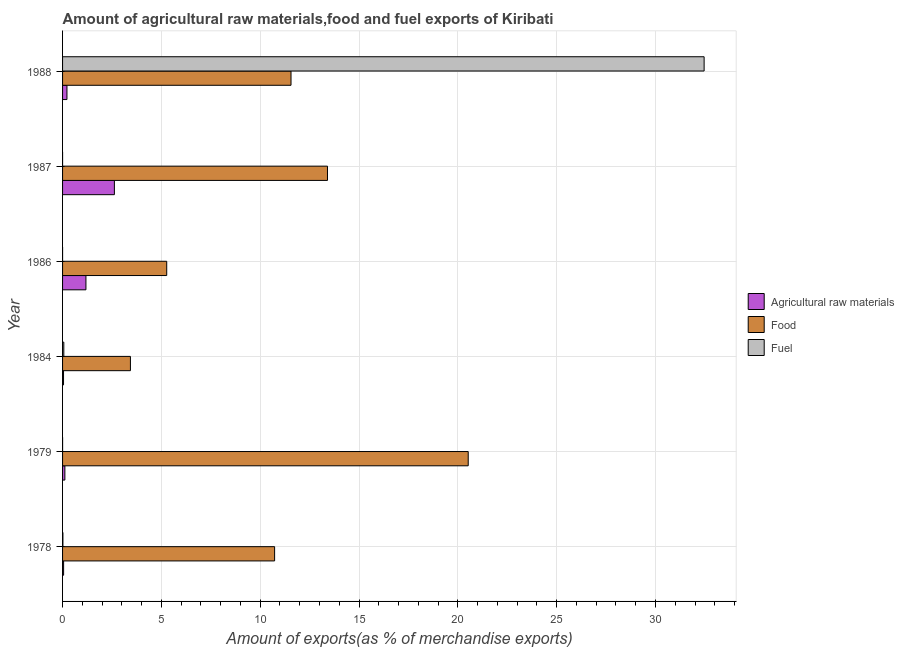Are the number of bars per tick equal to the number of legend labels?
Provide a succinct answer. Yes. Are the number of bars on each tick of the Y-axis equal?
Offer a very short reply. Yes. What is the percentage of fuel exports in 1978?
Make the answer very short. 0.02. Across all years, what is the maximum percentage of fuel exports?
Make the answer very short. 32.46. Across all years, what is the minimum percentage of raw materials exports?
Offer a terse response. 0.05. In which year was the percentage of food exports maximum?
Ensure brevity in your answer.  1979. What is the total percentage of fuel exports in the graph?
Provide a succinct answer. 32.54. What is the difference between the percentage of food exports in 1978 and that in 1979?
Keep it short and to the point. -9.79. What is the difference between the percentage of fuel exports in 1987 and the percentage of food exports in 1978?
Your answer should be very brief. -10.73. What is the average percentage of fuel exports per year?
Keep it short and to the point. 5.42. In the year 1988, what is the difference between the percentage of food exports and percentage of raw materials exports?
Make the answer very short. 11.34. What is the ratio of the percentage of fuel exports in 1979 to that in 1984?
Ensure brevity in your answer.  0. Is the difference between the percentage of raw materials exports in 1978 and 1987 greater than the difference between the percentage of fuel exports in 1978 and 1987?
Your answer should be very brief. No. What is the difference between the highest and the second highest percentage of raw materials exports?
Your answer should be very brief. 1.44. What is the difference between the highest and the lowest percentage of fuel exports?
Keep it short and to the point. 32.46. In how many years, is the percentage of fuel exports greater than the average percentage of fuel exports taken over all years?
Keep it short and to the point. 1. Is the sum of the percentage of raw materials exports in 1979 and 1987 greater than the maximum percentage of fuel exports across all years?
Offer a very short reply. No. What does the 1st bar from the top in 1986 represents?
Your answer should be compact. Fuel. What does the 2nd bar from the bottom in 1984 represents?
Keep it short and to the point. Food. Is it the case that in every year, the sum of the percentage of raw materials exports and percentage of food exports is greater than the percentage of fuel exports?
Provide a short and direct response. No. How many bars are there?
Keep it short and to the point. 18. Are all the bars in the graph horizontal?
Provide a succinct answer. Yes. How many years are there in the graph?
Keep it short and to the point. 6. Are the values on the major ticks of X-axis written in scientific E-notation?
Make the answer very short. No. Does the graph contain any zero values?
Provide a short and direct response. No. Does the graph contain grids?
Provide a succinct answer. Yes. Where does the legend appear in the graph?
Your response must be concise. Center right. How are the legend labels stacked?
Ensure brevity in your answer.  Vertical. What is the title of the graph?
Provide a short and direct response. Amount of agricultural raw materials,food and fuel exports of Kiribati. Does "Male employers" appear as one of the legend labels in the graph?
Your answer should be very brief. No. What is the label or title of the X-axis?
Your answer should be very brief. Amount of exports(as % of merchandise exports). What is the Amount of exports(as % of merchandise exports) in Agricultural raw materials in 1978?
Your answer should be compact. 0.05. What is the Amount of exports(as % of merchandise exports) in Food in 1978?
Make the answer very short. 10.73. What is the Amount of exports(as % of merchandise exports) in Fuel in 1978?
Provide a short and direct response. 0.02. What is the Amount of exports(as % of merchandise exports) of Agricultural raw materials in 1979?
Offer a terse response. 0.12. What is the Amount of exports(as % of merchandise exports) of Food in 1979?
Provide a succinct answer. 20.52. What is the Amount of exports(as % of merchandise exports) in Fuel in 1979?
Your response must be concise. 0. What is the Amount of exports(as % of merchandise exports) in Agricultural raw materials in 1984?
Offer a terse response. 0.05. What is the Amount of exports(as % of merchandise exports) of Food in 1984?
Offer a very short reply. 3.43. What is the Amount of exports(as % of merchandise exports) in Fuel in 1984?
Make the answer very short. 0.06. What is the Amount of exports(as % of merchandise exports) in Agricultural raw materials in 1986?
Provide a succinct answer. 1.18. What is the Amount of exports(as % of merchandise exports) in Food in 1986?
Your response must be concise. 5.27. What is the Amount of exports(as % of merchandise exports) of Fuel in 1986?
Provide a succinct answer. 0. What is the Amount of exports(as % of merchandise exports) of Agricultural raw materials in 1987?
Keep it short and to the point. 2.62. What is the Amount of exports(as % of merchandise exports) of Food in 1987?
Your answer should be compact. 13.4. What is the Amount of exports(as % of merchandise exports) in Fuel in 1987?
Offer a terse response. 0. What is the Amount of exports(as % of merchandise exports) of Agricultural raw materials in 1988?
Keep it short and to the point. 0.22. What is the Amount of exports(as % of merchandise exports) of Food in 1988?
Provide a succinct answer. 11.56. What is the Amount of exports(as % of merchandise exports) in Fuel in 1988?
Make the answer very short. 32.46. Across all years, what is the maximum Amount of exports(as % of merchandise exports) in Agricultural raw materials?
Your answer should be compact. 2.62. Across all years, what is the maximum Amount of exports(as % of merchandise exports) in Food?
Offer a very short reply. 20.52. Across all years, what is the maximum Amount of exports(as % of merchandise exports) of Fuel?
Ensure brevity in your answer.  32.46. Across all years, what is the minimum Amount of exports(as % of merchandise exports) in Agricultural raw materials?
Provide a succinct answer. 0.05. Across all years, what is the minimum Amount of exports(as % of merchandise exports) in Food?
Provide a succinct answer. 3.43. Across all years, what is the minimum Amount of exports(as % of merchandise exports) in Fuel?
Offer a very short reply. 0. What is the total Amount of exports(as % of merchandise exports) in Agricultural raw materials in the graph?
Give a very brief answer. 4.25. What is the total Amount of exports(as % of merchandise exports) in Food in the graph?
Ensure brevity in your answer.  64.92. What is the total Amount of exports(as % of merchandise exports) of Fuel in the graph?
Provide a succinct answer. 32.54. What is the difference between the Amount of exports(as % of merchandise exports) of Agricultural raw materials in 1978 and that in 1979?
Your answer should be very brief. -0.06. What is the difference between the Amount of exports(as % of merchandise exports) in Food in 1978 and that in 1979?
Keep it short and to the point. -9.8. What is the difference between the Amount of exports(as % of merchandise exports) of Fuel in 1978 and that in 1979?
Ensure brevity in your answer.  0.02. What is the difference between the Amount of exports(as % of merchandise exports) in Agricultural raw materials in 1978 and that in 1984?
Offer a very short reply. 0. What is the difference between the Amount of exports(as % of merchandise exports) in Food in 1978 and that in 1984?
Ensure brevity in your answer.  7.29. What is the difference between the Amount of exports(as % of merchandise exports) in Fuel in 1978 and that in 1984?
Ensure brevity in your answer.  -0.05. What is the difference between the Amount of exports(as % of merchandise exports) in Agricultural raw materials in 1978 and that in 1986?
Provide a short and direct response. -1.13. What is the difference between the Amount of exports(as % of merchandise exports) of Food in 1978 and that in 1986?
Offer a terse response. 5.46. What is the difference between the Amount of exports(as % of merchandise exports) in Fuel in 1978 and that in 1986?
Provide a short and direct response. 0.02. What is the difference between the Amount of exports(as % of merchandise exports) in Agricultural raw materials in 1978 and that in 1987?
Your response must be concise. -2.57. What is the difference between the Amount of exports(as % of merchandise exports) of Food in 1978 and that in 1987?
Your response must be concise. -2.68. What is the difference between the Amount of exports(as % of merchandise exports) of Fuel in 1978 and that in 1987?
Give a very brief answer. 0.02. What is the difference between the Amount of exports(as % of merchandise exports) of Agricultural raw materials in 1978 and that in 1988?
Give a very brief answer. -0.17. What is the difference between the Amount of exports(as % of merchandise exports) in Food in 1978 and that in 1988?
Your answer should be compact. -0.83. What is the difference between the Amount of exports(as % of merchandise exports) of Fuel in 1978 and that in 1988?
Provide a succinct answer. -32.44. What is the difference between the Amount of exports(as % of merchandise exports) of Agricultural raw materials in 1979 and that in 1984?
Provide a succinct answer. 0.07. What is the difference between the Amount of exports(as % of merchandise exports) in Food in 1979 and that in 1984?
Make the answer very short. 17.09. What is the difference between the Amount of exports(as % of merchandise exports) in Fuel in 1979 and that in 1984?
Offer a very short reply. -0.06. What is the difference between the Amount of exports(as % of merchandise exports) in Agricultural raw materials in 1979 and that in 1986?
Offer a very short reply. -1.07. What is the difference between the Amount of exports(as % of merchandise exports) of Food in 1979 and that in 1986?
Ensure brevity in your answer.  15.25. What is the difference between the Amount of exports(as % of merchandise exports) in Fuel in 1979 and that in 1986?
Offer a terse response. 0. What is the difference between the Amount of exports(as % of merchandise exports) of Agricultural raw materials in 1979 and that in 1987?
Keep it short and to the point. -2.51. What is the difference between the Amount of exports(as % of merchandise exports) of Food in 1979 and that in 1987?
Give a very brief answer. 7.12. What is the difference between the Amount of exports(as % of merchandise exports) in Agricultural raw materials in 1979 and that in 1988?
Provide a succinct answer. -0.11. What is the difference between the Amount of exports(as % of merchandise exports) of Food in 1979 and that in 1988?
Give a very brief answer. 8.96. What is the difference between the Amount of exports(as % of merchandise exports) in Fuel in 1979 and that in 1988?
Offer a terse response. -32.46. What is the difference between the Amount of exports(as % of merchandise exports) of Agricultural raw materials in 1984 and that in 1986?
Your response must be concise. -1.13. What is the difference between the Amount of exports(as % of merchandise exports) in Food in 1984 and that in 1986?
Your response must be concise. -1.84. What is the difference between the Amount of exports(as % of merchandise exports) of Fuel in 1984 and that in 1986?
Provide a succinct answer. 0.06. What is the difference between the Amount of exports(as % of merchandise exports) of Agricultural raw materials in 1984 and that in 1987?
Offer a very short reply. -2.57. What is the difference between the Amount of exports(as % of merchandise exports) in Food in 1984 and that in 1987?
Ensure brevity in your answer.  -9.97. What is the difference between the Amount of exports(as % of merchandise exports) in Fuel in 1984 and that in 1987?
Offer a very short reply. 0.06. What is the difference between the Amount of exports(as % of merchandise exports) of Agricultural raw materials in 1984 and that in 1988?
Offer a very short reply. -0.17. What is the difference between the Amount of exports(as % of merchandise exports) in Food in 1984 and that in 1988?
Offer a very short reply. -8.13. What is the difference between the Amount of exports(as % of merchandise exports) in Fuel in 1984 and that in 1988?
Ensure brevity in your answer.  -32.4. What is the difference between the Amount of exports(as % of merchandise exports) in Agricultural raw materials in 1986 and that in 1987?
Make the answer very short. -1.44. What is the difference between the Amount of exports(as % of merchandise exports) of Food in 1986 and that in 1987?
Give a very brief answer. -8.13. What is the difference between the Amount of exports(as % of merchandise exports) in Fuel in 1986 and that in 1987?
Give a very brief answer. -0. What is the difference between the Amount of exports(as % of merchandise exports) in Agricultural raw materials in 1986 and that in 1988?
Offer a terse response. 0.96. What is the difference between the Amount of exports(as % of merchandise exports) of Food in 1986 and that in 1988?
Your answer should be compact. -6.29. What is the difference between the Amount of exports(as % of merchandise exports) in Fuel in 1986 and that in 1988?
Give a very brief answer. -32.46. What is the difference between the Amount of exports(as % of merchandise exports) in Agricultural raw materials in 1987 and that in 1988?
Provide a short and direct response. 2.4. What is the difference between the Amount of exports(as % of merchandise exports) of Food in 1987 and that in 1988?
Ensure brevity in your answer.  1.85. What is the difference between the Amount of exports(as % of merchandise exports) of Fuel in 1987 and that in 1988?
Offer a very short reply. -32.46. What is the difference between the Amount of exports(as % of merchandise exports) in Agricultural raw materials in 1978 and the Amount of exports(as % of merchandise exports) in Food in 1979?
Keep it short and to the point. -20.47. What is the difference between the Amount of exports(as % of merchandise exports) of Agricultural raw materials in 1978 and the Amount of exports(as % of merchandise exports) of Fuel in 1979?
Make the answer very short. 0.05. What is the difference between the Amount of exports(as % of merchandise exports) in Food in 1978 and the Amount of exports(as % of merchandise exports) in Fuel in 1979?
Provide a succinct answer. 10.73. What is the difference between the Amount of exports(as % of merchandise exports) in Agricultural raw materials in 1978 and the Amount of exports(as % of merchandise exports) in Food in 1984?
Keep it short and to the point. -3.38. What is the difference between the Amount of exports(as % of merchandise exports) of Agricultural raw materials in 1978 and the Amount of exports(as % of merchandise exports) of Fuel in 1984?
Ensure brevity in your answer.  -0.01. What is the difference between the Amount of exports(as % of merchandise exports) of Food in 1978 and the Amount of exports(as % of merchandise exports) of Fuel in 1984?
Your answer should be very brief. 10.67. What is the difference between the Amount of exports(as % of merchandise exports) in Agricultural raw materials in 1978 and the Amount of exports(as % of merchandise exports) in Food in 1986?
Your response must be concise. -5.22. What is the difference between the Amount of exports(as % of merchandise exports) in Agricultural raw materials in 1978 and the Amount of exports(as % of merchandise exports) in Fuel in 1986?
Make the answer very short. 0.05. What is the difference between the Amount of exports(as % of merchandise exports) of Food in 1978 and the Amount of exports(as % of merchandise exports) of Fuel in 1986?
Your answer should be compact. 10.73. What is the difference between the Amount of exports(as % of merchandise exports) of Agricultural raw materials in 1978 and the Amount of exports(as % of merchandise exports) of Food in 1987?
Provide a succinct answer. -13.35. What is the difference between the Amount of exports(as % of merchandise exports) of Agricultural raw materials in 1978 and the Amount of exports(as % of merchandise exports) of Fuel in 1987?
Provide a succinct answer. 0.05. What is the difference between the Amount of exports(as % of merchandise exports) of Food in 1978 and the Amount of exports(as % of merchandise exports) of Fuel in 1987?
Your answer should be compact. 10.73. What is the difference between the Amount of exports(as % of merchandise exports) in Agricultural raw materials in 1978 and the Amount of exports(as % of merchandise exports) in Food in 1988?
Make the answer very short. -11.51. What is the difference between the Amount of exports(as % of merchandise exports) in Agricultural raw materials in 1978 and the Amount of exports(as % of merchandise exports) in Fuel in 1988?
Keep it short and to the point. -32.41. What is the difference between the Amount of exports(as % of merchandise exports) in Food in 1978 and the Amount of exports(as % of merchandise exports) in Fuel in 1988?
Offer a very short reply. -21.73. What is the difference between the Amount of exports(as % of merchandise exports) of Agricultural raw materials in 1979 and the Amount of exports(as % of merchandise exports) of Food in 1984?
Offer a very short reply. -3.32. What is the difference between the Amount of exports(as % of merchandise exports) of Agricultural raw materials in 1979 and the Amount of exports(as % of merchandise exports) of Fuel in 1984?
Keep it short and to the point. 0.05. What is the difference between the Amount of exports(as % of merchandise exports) of Food in 1979 and the Amount of exports(as % of merchandise exports) of Fuel in 1984?
Your answer should be very brief. 20.46. What is the difference between the Amount of exports(as % of merchandise exports) of Agricultural raw materials in 1979 and the Amount of exports(as % of merchandise exports) of Food in 1986?
Your response must be concise. -5.15. What is the difference between the Amount of exports(as % of merchandise exports) of Agricultural raw materials in 1979 and the Amount of exports(as % of merchandise exports) of Fuel in 1986?
Your answer should be very brief. 0.12. What is the difference between the Amount of exports(as % of merchandise exports) of Food in 1979 and the Amount of exports(as % of merchandise exports) of Fuel in 1986?
Your answer should be compact. 20.52. What is the difference between the Amount of exports(as % of merchandise exports) of Agricultural raw materials in 1979 and the Amount of exports(as % of merchandise exports) of Food in 1987?
Provide a succinct answer. -13.29. What is the difference between the Amount of exports(as % of merchandise exports) in Agricultural raw materials in 1979 and the Amount of exports(as % of merchandise exports) in Fuel in 1987?
Offer a terse response. 0.12. What is the difference between the Amount of exports(as % of merchandise exports) of Food in 1979 and the Amount of exports(as % of merchandise exports) of Fuel in 1987?
Provide a succinct answer. 20.52. What is the difference between the Amount of exports(as % of merchandise exports) in Agricultural raw materials in 1979 and the Amount of exports(as % of merchandise exports) in Food in 1988?
Your answer should be very brief. -11.44. What is the difference between the Amount of exports(as % of merchandise exports) in Agricultural raw materials in 1979 and the Amount of exports(as % of merchandise exports) in Fuel in 1988?
Your answer should be compact. -32.34. What is the difference between the Amount of exports(as % of merchandise exports) of Food in 1979 and the Amount of exports(as % of merchandise exports) of Fuel in 1988?
Your answer should be compact. -11.94. What is the difference between the Amount of exports(as % of merchandise exports) of Agricultural raw materials in 1984 and the Amount of exports(as % of merchandise exports) of Food in 1986?
Provide a short and direct response. -5.22. What is the difference between the Amount of exports(as % of merchandise exports) of Agricultural raw materials in 1984 and the Amount of exports(as % of merchandise exports) of Fuel in 1986?
Your answer should be compact. 0.05. What is the difference between the Amount of exports(as % of merchandise exports) in Food in 1984 and the Amount of exports(as % of merchandise exports) in Fuel in 1986?
Make the answer very short. 3.43. What is the difference between the Amount of exports(as % of merchandise exports) of Agricultural raw materials in 1984 and the Amount of exports(as % of merchandise exports) of Food in 1987?
Ensure brevity in your answer.  -13.35. What is the difference between the Amount of exports(as % of merchandise exports) of Agricultural raw materials in 1984 and the Amount of exports(as % of merchandise exports) of Fuel in 1987?
Offer a very short reply. 0.05. What is the difference between the Amount of exports(as % of merchandise exports) in Food in 1984 and the Amount of exports(as % of merchandise exports) in Fuel in 1987?
Keep it short and to the point. 3.43. What is the difference between the Amount of exports(as % of merchandise exports) of Agricultural raw materials in 1984 and the Amount of exports(as % of merchandise exports) of Food in 1988?
Ensure brevity in your answer.  -11.51. What is the difference between the Amount of exports(as % of merchandise exports) in Agricultural raw materials in 1984 and the Amount of exports(as % of merchandise exports) in Fuel in 1988?
Provide a short and direct response. -32.41. What is the difference between the Amount of exports(as % of merchandise exports) of Food in 1984 and the Amount of exports(as % of merchandise exports) of Fuel in 1988?
Ensure brevity in your answer.  -29.03. What is the difference between the Amount of exports(as % of merchandise exports) in Agricultural raw materials in 1986 and the Amount of exports(as % of merchandise exports) in Food in 1987?
Provide a short and direct response. -12.22. What is the difference between the Amount of exports(as % of merchandise exports) in Agricultural raw materials in 1986 and the Amount of exports(as % of merchandise exports) in Fuel in 1987?
Your answer should be compact. 1.18. What is the difference between the Amount of exports(as % of merchandise exports) of Food in 1986 and the Amount of exports(as % of merchandise exports) of Fuel in 1987?
Your answer should be very brief. 5.27. What is the difference between the Amount of exports(as % of merchandise exports) in Agricultural raw materials in 1986 and the Amount of exports(as % of merchandise exports) in Food in 1988?
Your answer should be compact. -10.38. What is the difference between the Amount of exports(as % of merchandise exports) in Agricultural raw materials in 1986 and the Amount of exports(as % of merchandise exports) in Fuel in 1988?
Your response must be concise. -31.28. What is the difference between the Amount of exports(as % of merchandise exports) of Food in 1986 and the Amount of exports(as % of merchandise exports) of Fuel in 1988?
Give a very brief answer. -27.19. What is the difference between the Amount of exports(as % of merchandise exports) of Agricultural raw materials in 1987 and the Amount of exports(as % of merchandise exports) of Food in 1988?
Provide a short and direct response. -8.94. What is the difference between the Amount of exports(as % of merchandise exports) in Agricultural raw materials in 1987 and the Amount of exports(as % of merchandise exports) in Fuel in 1988?
Your answer should be very brief. -29.84. What is the difference between the Amount of exports(as % of merchandise exports) of Food in 1987 and the Amount of exports(as % of merchandise exports) of Fuel in 1988?
Ensure brevity in your answer.  -19.05. What is the average Amount of exports(as % of merchandise exports) of Agricultural raw materials per year?
Give a very brief answer. 0.71. What is the average Amount of exports(as % of merchandise exports) of Food per year?
Ensure brevity in your answer.  10.82. What is the average Amount of exports(as % of merchandise exports) in Fuel per year?
Your answer should be compact. 5.42. In the year 1978, what is the difference between the Amount of exports(as % of merchandise exports) of Agricultural raw materials and Amount of exports(as % of merchandise exports) of Food?
Keep it short and to the point. -10.68. In the year 1978, what is the difference between the Amount of exports(as % of merchandise exports) of Agricultural raw materials and Amount of exports(as % of merchandise exports) of Fuel?
Offer a terse response. 0.04. In the year 1978, what is the difference between the Amount of exports(as % of merchandise exports) in Food and Amount of exports(as % of merchandise exports) in Fuel?
Make the answer very short. 10.71. In the year 1979, what is the difference between the Amount of exports(as % of merchandise exports) of Agricultural raw materials and Amount of exports(as % of merchandise exports) of Food?
Your answer should be very brief. -20.41. In the year 1979, what is the difference between the Amount of exports(as % of merchandise exports) of Agricultural raw materials and Amount of exports(as % of merchandise exports) of Fuel?
Offer a terse response. 0.12. In the year 1979, what is the difference between the Amount of exports(as % of merchandise exports) in Food and Amount of exports(as % of merchandise exports) in Fuel?
Provide a succinct answer. 20.52. In the year 1984, what is the difference between the Amount of exports(as % of merchandise exports) of Agricultural raw materials and Amount of exports(as % of merchandise exports) of Food?
Offer a terse response. -3.38. In the year 1984, what is the difference between the Amount of exports(as % of merchandise exports) of Agricultural raw materials and Amount of exports(as % of merchandise exports) of Fuel?
Provide a succinct answer. -0.01. In the year 1984, what is the difference between the Amount of exports(as % of merchandise exports) in Food and Amount of exports(as % of merchandise exports) in Fuel?
Give a very brief answer. 3.37. In the year 1986, what is the difference between the Amount of exports(as % of merchandise exports) in Agricultural raw materials and Amount of exports(as % of merchandise exports) in Food?
Your response must be concise. -4.09. In the year 1986, what is the difference between the Amount of exports(as % of merchandise exports) of Agricultural raw materials and Amount of exports(as % of merchandise exports) of Fuel?
Your response must be concise. 1.18. In the year 1986, what is the difference between the Amount of exports(as % of merchandise exports) of Food and Amount of exports(as % of merchandise exports) of Fuel?
Make the answer very short. 5.27. In the year 1987, what is the difference between the Amount of exports(as % of merchandise exports) of Agricultural raw materials and Amount of exports(as % of merchandise exports) of Food?
Provide a succinct answer. -10.78. In the year 1987, what is the difference between the Amount of exports(as % of merchandise exports) of Agricultural raw materials and Amount of exports(as % of merchandise exports) of Fuel?
Provide a short and direct response. 2.62. In the year 1987, what is the difference between the Amount of exports(as % of merchandise exports) in Food and Amount of exports(as % of merchandise exports) in Fuel?
Offer a terse response. 13.4. In the year 1988, what is the difference between the Amount of exports(as % of merchandise exports) in Agricultural raw materials and Amount of exports(as % of merchandise exports) in Food?
Make the answer very short. -11.34. In the year 1988, what is the difference between the Amount of exports(as % of merchandise exports) in Agricultural raw materials and Amount of exports(as % of merchandise exports) in Fuel?
Provide a short and direct response. -32.24. In the year 1988, what is the difference between the Amount of exports(as % of merchandise exports) of Food and Amount of exports(as % of merchandise exports) of Fuel?
Offer a terse response. -20.9. What is the ratio of the Amount of exports(as % of merchandise exports) of Agricultural raw materials in 1978 to that in 1979?
Provide a succinct answer. 0.45. What is the ratio of the Amount of exports(as % of merchandise exports) of Food in 1978 to that in 1979?
Offer a terse response. 0.52. What is the ratio of the Amount of exports(as % of merchandise exports) in Fuel in 1978 to that in 1979?
Keep it short and to the point. 69.38. What is the ratio of the Amount of exports(as % of merchandise exports) in Agricultural raw materials in 1978 to that in 1984?
Offer a very short reply. 1.08. What is the ratio of the Amount of exports(as % of merchandise exports) in Food in 1978 to that in 1984?
Give a very brief answer. 3.12. What is the ratio of the Amount of exports(as % of merchandise exports) in Fuel in 1978 to that in 1984?
Offer a terse response. 0.27. What is the ratio of the Amount of exports(as % of merchandise exports) in Agricultural raw materials in 1978 to that in 1986?
Ensure brevity in your answer.  0.04. What is the ratio of the Amount of exports(as % of merchandise exports) of Food in 1978 to that in 1986?
Keep it short and to the point. 2.04. What is the ratio of the Amount of exports(as % of merchandise exports) of Fuel in 1978 to that in 1986?
Your answer should be compact. 147.01. What is the ratio of the Amount of exports(as % of merchandise exports) of Agricultural raw materials in 1978 to that in 1987?
Provide a succinct answer. 0.02. What is the ratio of the Amount of exports(as % of merchandise exports) of Food in 1978 to that in 1987?
Ensure brevity in your answer.  0.8. What is the ratio of the Amount of exports(as % of merchandise exports) in Fuel in 1978 to that in 1987?
Make the answer very short. 99.44. What is the ratio of the Amount of exports(as % of merchandise exports) in Agricultural raw materials in 1978 to that in 1988?
Your answer should be compact. 0.24. What is the ratio of the Amount of exports(as % of merchandise exports) in Food in 1978 to that in 1988?
Offer a very short reply. 0.93. What is the ratio of the Amount of exports(as % of merchandise exports) of Agricultural raw materials in 1979 to that in 1984?
Provide a short and direct response. 2.38. What is the ratio of the Amount of exports(as % of merchandise exports) in Food in 1979 to that in 1984?
Provide a short and direct response. 5.98. What is the ratio of the Amount of exports(as % of merchandise exports) in Fuel in 1979 to that in 1984?
Ensure brevity in your answer.  0. What is the ratio of the Amount of exports(as % of merchandise exports) in Agricultural raw materials in 1979 to that in 1986?
Give a very brief answer. 0.1. What is the ratio of the Amount of exports(as % of merchandise exports) in Food in 1979 to that in 1986?
Ensure brevity in your answer.  3.89. What is the ratio of the Amount of exports(as % of merchandise exports) in Fuel in 1979 to that in 1986?
Offer a terse response. 2.12. What is the ratio of the Amount of exports(as % of merchandise exports) in Agricultural raw materials in 1979 to that in 1987?
Offer a very short reply. 0.04. What is the ratio of the Amount of exports(as % of merchandise exports) in Food in 1979 to that in 1987?
Provide a succinct answer. 1.53. What is the ratio of the Amount of exports(as % of merchandise exports) in Fuel in 1979 to that in 1987?
Your answer should be very brief. 1.43. What is the ratio of the Amount of exports(as % of merchandise exports) of Agricultural raw materials in 1979 to that in 1988?
Offer a terse response. 0.53. What is the ratio of the Amount of exports(as % of merchandise exports) in Food in 1979 to that in 1988?
Offer a terse response. 1.78. What is the ratio of the Amount of exports(as % of merchandise exports) in Fuel in 1979 to that in 1988?
Offer a terse response. 0. What is the ratio of the Amount of exports(as % of merchandise exports) of Agricultural raw materials in 1984 to that in 1986?
Give a very brief answer. 0.04. What is the ratio of the Amount of exports(as % of merchandise exports) of Food in 1984 to that in 1986?
Offer a very short reply. 0.65. What is the ratio of the Amount of exports(as % of merchandise exports) of Fuel in 1984 to that in 1986?
Your answer should be compact. 540.83. What is the ratio of the Amount of exports(as % of merchandise exports) of Agricultural raw materials in 1984 to that in 1987?
Your answer should be compact. 0.02. What is the ratio of the Amount of exports(as % of merchandise exports) of Food in 1984 to that in 1987?
Keep it short and to the point. 0.26. What is the ratio of the Amount of exports(as % of merchandise exports) of Fuel in 1984 to that in 1987?
Provide a succinct answer. 365.82. What is the ratio of the Amount of exports(as % of merchandise exports) of Agricultural raw materials in 1984 to that in 1988?
Give a very brief answer. 0.22. What is the ratio of the Amount of exports(as % of merchandise exports) of Food in 1984 to that in 1988?
Offer a terse response. 0.3. What is the ratio of the Amount of exports(as % of merchandise exports) in Fuel in 1984 to that in 1988?
Offer a terse response. 0. What is the ratio of the Amount of exports(as % of merchandise exports) in Agricultural raw materials in 1986 to that in 1987?
Your answer should be very brief. 0.45. What is the ratio of the Amount of exports(as % of merchandise exports) of Food in 1986 to that in 1987?
Keep it short and to the point. 0.39. What is the ratio of the Amount of exports(as % of merchandise exports) in Fuel in 1986 to that in 1987?
Provide a succinct answer. 0.68. What is the ratio of the Amount of exports(as % of merchandise exports) in Agricultural raw materials in 1986 to that in 1988?
Provide a succinct answer. 5.32. What is the ratio of the Amount of exports(as % of merchandise exports) in Food in 1986 to that in 1988?
Your response must be concise. 0.46. What is the ratio of the Amount of exports(as % of merchandise exports) of Agricultural raw materials in 1987 to that in 1988?
Provide a succinct answer. 11.79. What is the ratio of the Amount of exports(as % of merchandise exports) in Food in 1987 to that in 1988?
Ensure brevity in your answer.  1.16. What is the ratio of the Amount of exports(as % of merchandise exports) in Fuel in 1987 to that in 1988?
Make the answer very short. 0. What is the difference between the highest and the second highest Amount of exports(as % of merchandise exports) in Agricultural raw materials?
Your response must be concise. 1.44. What is the difference between the highest and the second highest Amount of exports(as % of merchandise exports) of Food?
Your answer should be very brief. 7.12. What is the difference between the highest and the second highest Amount of exports(as % of merchandise exports) in Fuel?
Provide a short and direct response. 32.4. What is the difference between the highest and the lowest Amount of exports(as % of merchandise exports) of Agricultural raw materials?
Give a very brief answer. 2.57. What is the difference between the highest and the lowest Amount of exports(as % of merchandise exports) of Food?
Your answer should be very brief. 17.09. What is the difference between the highest and the lowest Amount of exports(as % of merchandise exports) of Fuel?
Keep it short and to the point. 32.46. 